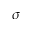Convert formula to latex. <formula><loc_0><loc_0><loc_500><loc_500>\sigma</formula> 